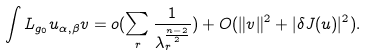Convert formula to latex. <formula><loc_0><loc_0><loc_500><loc_500>\int L _ { g _ { 0 } } u _ { \alpha , \beta } v = o ( \sum _ { r } \frac { 1 } { \lambda _ { r } ^ { \frac { n - 2 } { 2 } } } ) + O ( \| v \| ^ { 2 } + | \delta J ( u ) | ^ { 2 } ) .</formula> 